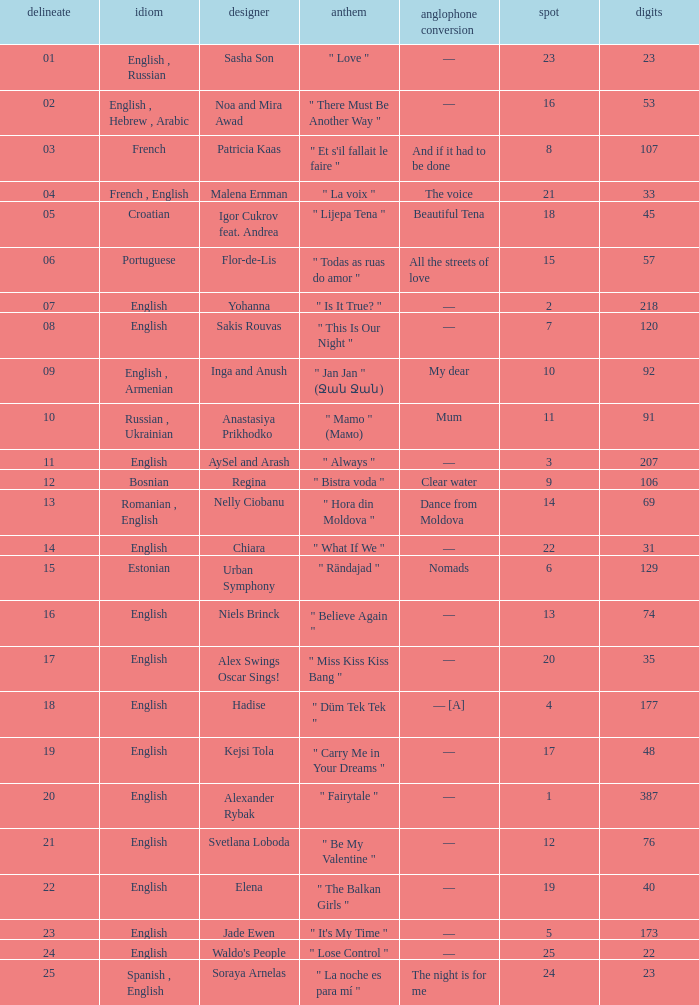Can you give me this table as a dict? {'header': ['delineate', 'idiom', 'designer', 'anthem', 'anglophone conversion', 'spot', 'digits'], 'rows': [['01', 'English , Russian', 'Sasha Son', '" Love "', '—', '23', '23'], ['02', 'English , Hebrew , Arabic', 'Noa and Mira Awad', '" There Must Be Another Way "', '—', '16', '53'], ['03', 'French', 'Patricia Kaas', '" Et s\'il fallait le faire "', 'And if it had to be done', '8', '107'], ['04', 'French , English', 'Malena Ernman', '" La voix "', 'The voice', '21', '33'], ['05', 'Croatian', 'Igor Cukrov feat. Andrea', '" Lijepa Tena "', 'Beautiful Tena', '18', '45'], ['06', 'Portuguese', 'Flor-de-Lis', '" Todas as ruas do amor "', 'All the streets of love', '15', '57'], ['07', 'English', 'Yohanna', '" Is It True? "', '—', '2', '218'], ['08', 'English', 'Sakis Rouvas', '" This Is Our Night "', '—', '7', '120'], ['09', 'English , Armenian', 'Inga and Anush', '" Jan Jan " (Ջան Ջան)', 'My dear', '10', '92'], ['10', 'Russian , Ukrainian', 'Anastasiya Prikhodko', '" Mamo " (Мамо)', 'Mum', '11', '91'], ['11', 'English', 'AySel and Arash', '" Always "', '—', '3', '207'], ['12', 'Bosnian', 'Regina', '" Bistra voda "', 'Clear water', '9', '106'], ['13', 'Romanian , English', 'Nelly Ciobanu', '" Hora din Moldova "', 'Dance from Moldova', '14', '69'], ['14', 'English', 'Chiara', '" What If We "', '—', '22', '31'], ['15', 'Estonian', 'Urban Symphony', '" Rändajad "', 'Nomads', '6', '129'], ['16', 'English', 'Niels Brinck', '" Believe Again "', '—', '13', '74'], ['17', 'English', 'Alex Swings Oscar Sings!', '" Miss Kiss Kiss Bang "', '—', '20', '35'], ['18', 'English', 'Hadise', '" Düm Tek Tek "', '— [A]', '4', '177'], ['19', 'English', 'Kejsi Tola', '" Carry Me in Your Dreams "', '—', '17', '48'], ['20', 'English', 'Alexander Rybak', '" Fairytale "', '—', '1', '387'], ['21', 'English', 'Svetlana Loboda', '" Be My Valentine "', '—', '12', '76'], ['22', 'English', 'Elena', '" The Balkan Girls "', '—', '19', '40'], ['23', 'English', 'Jade Ewen', '" It\'s My Time "', '—', '5', '173'], ['24', 'English', "Waldo's People", '" Lose Control "', '—', '25', '22'], ['25', 'Spanish , English', 'Soraya Arnelas', '" La noche es para mí "', 'The night is for me', '24', '23']]} What was the english translation for the song by svetlana loboda? —. 